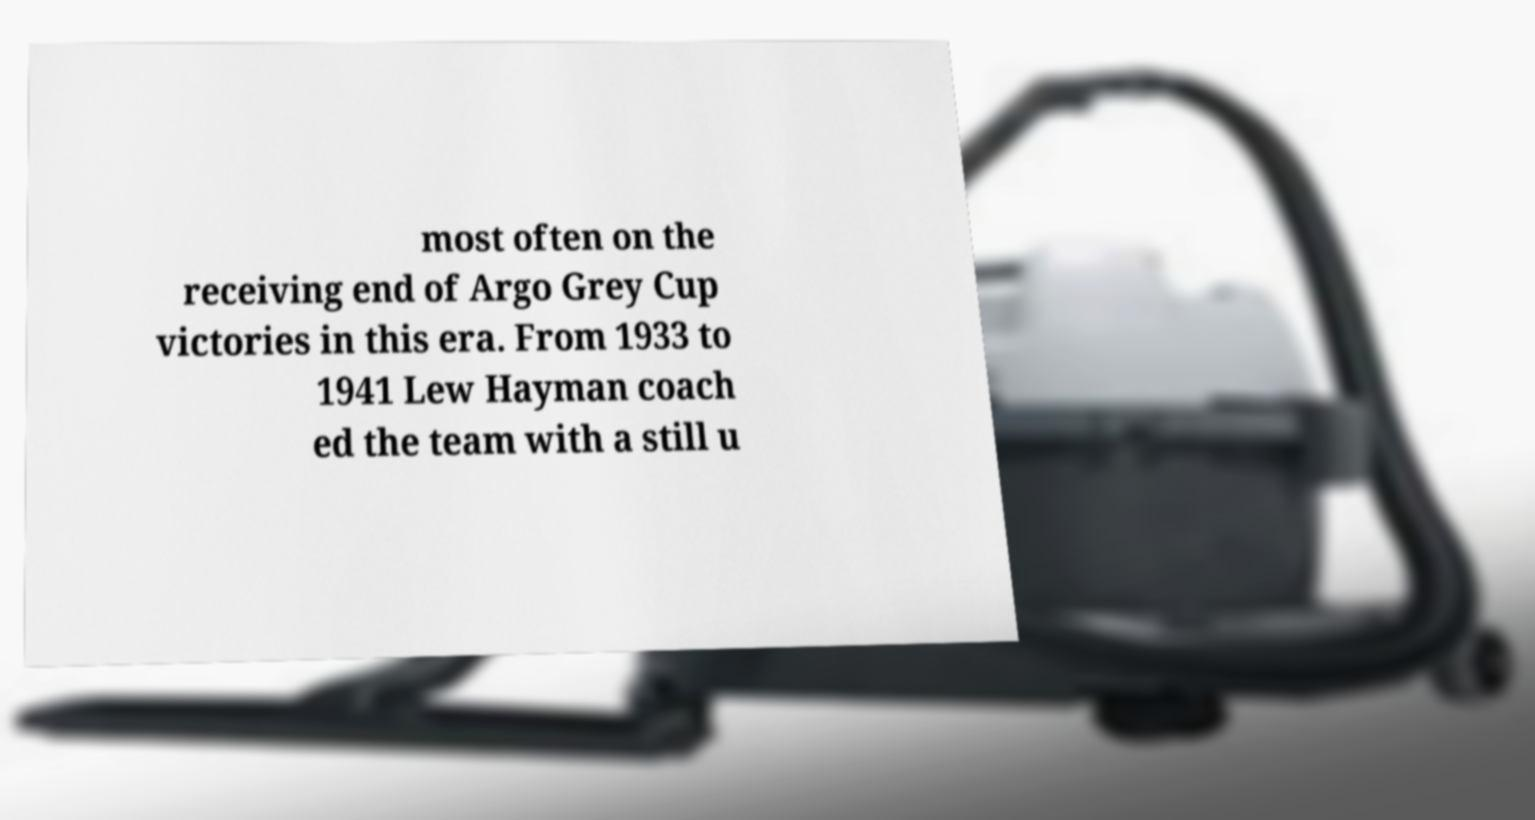I need the written content from this picture converted into text. Can you do that? most often on the receiving end of Argo Grey Cup victories in this era. From 1933 to 1941 Lew Hayman coach ed the team with a still u 